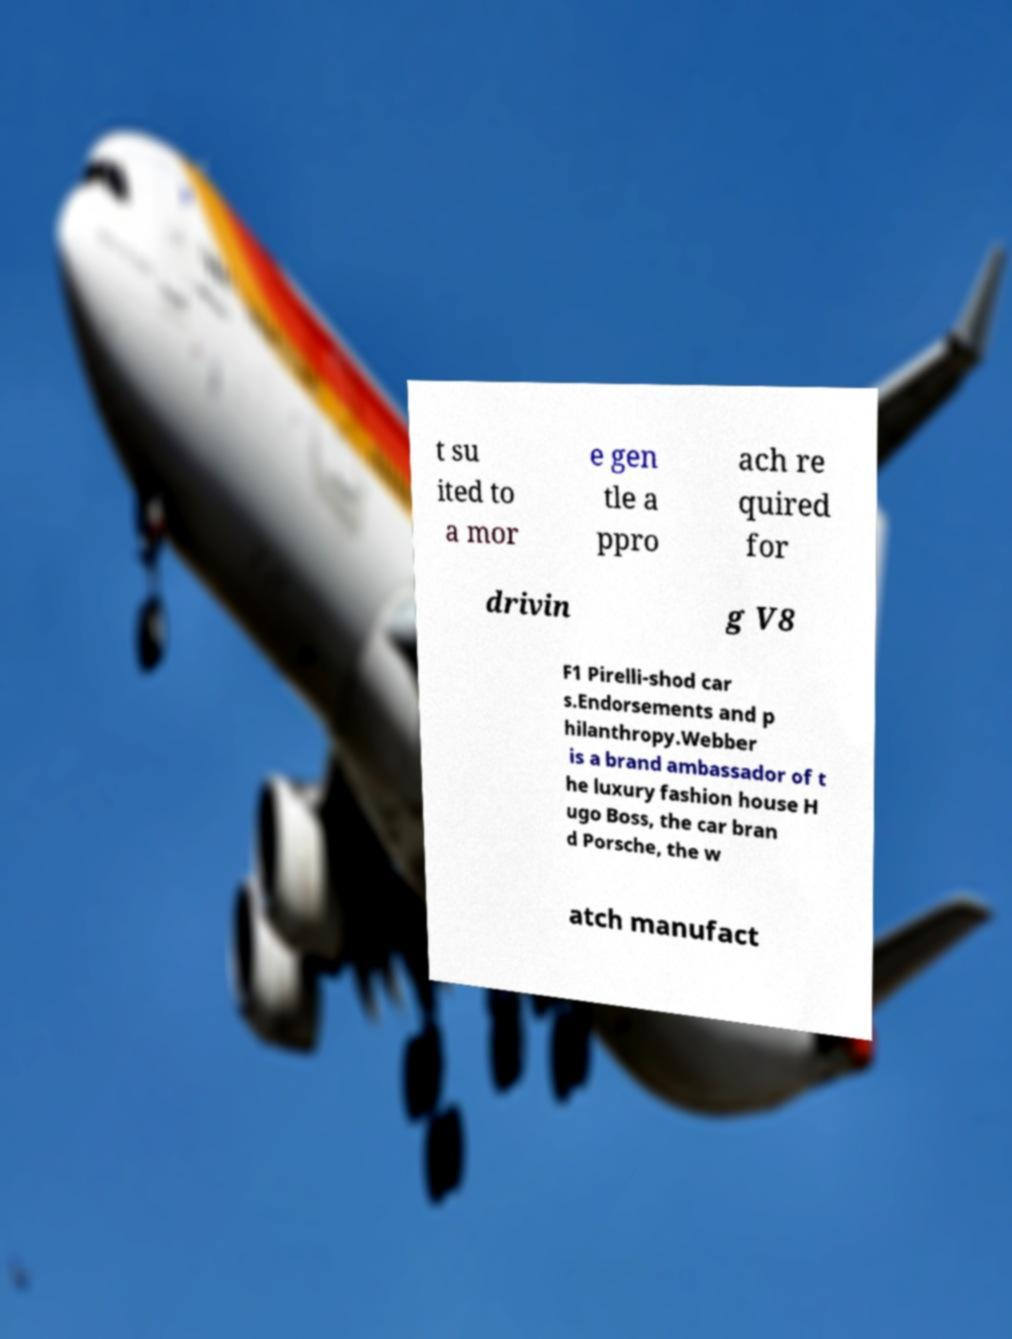What messages or text are displayed in this image? I need them in a readable, typed format. t su ited to a mor e gen tle a ppro ach re quired for drivin g V8 F1 Pirelli-shod car s.Endorsements and p hilanthropy.Webber is a brand ambassador of t he luxury fashion house H ugo Boss, the car bran d Porsche, the w atch manufact 